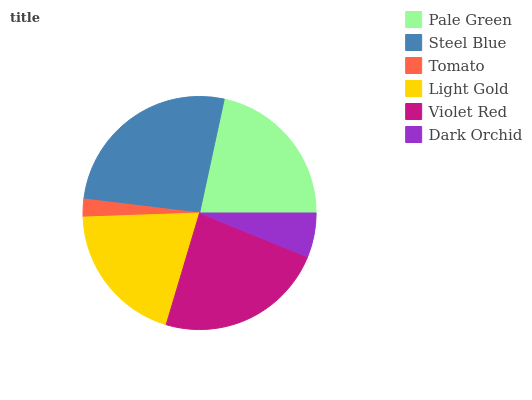Is Tomato the minimum?
Answer yes or no. Yes. Is Steel Blue the maximum?
Answer yes or no. Yes. Is Steel Blue the minimum?
Answer yes or no. No. Is Tomato the maximum?
Answer yes or no. No. Is Steel Blue greater than Tomato?
Answer yes or no. Yes. Is Tomato less than Steel Blue?
Answer yes or no. Yes. Is Tomato greater than Steel Blue?
Answer yes or no. No. Is Steel Blue less than Tomato?
Answer yes or no. No. Is Pale Green the high median?
Answer yes or no. Yes. Is Light Gold the low median?
Answer yes or no. Yes. Is Steel Blue the high median?
Answer yes or no. No. Is Pale Green the low median?
Answer yes or no. No. 